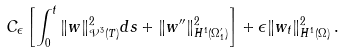<formula> <loc_0><loc_0><loc_500><loc_500>C _ { \epsilon } \left [ \int _ { 0 } ^ { t } \| w \| ^ { 2 } _ { { \mathcal { V } } ^ { 3 } ( T ) } d s + \| w ^ { \prime \prime } \| ^ { 2 } _ { H ^ { 1 } ( \Omega _ { 1 } ^ { \prime } ) } \right ] + \epsilon \| w _ { t } \| ^ { 2 } _ { H ^ { 1 } ( \Omega ) } \, .</formula> 